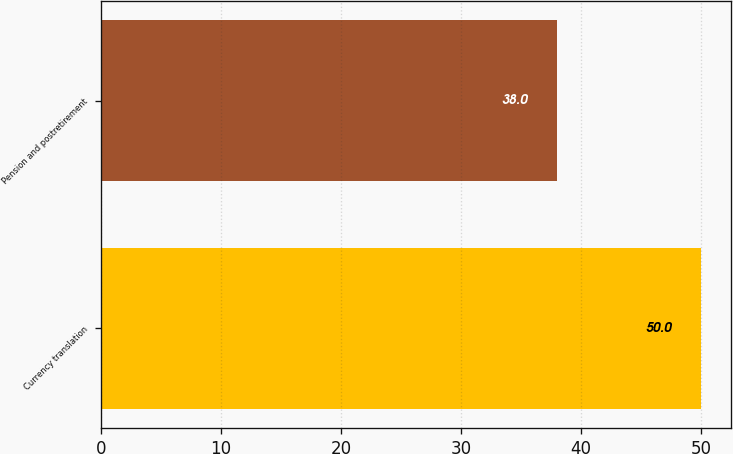<chart> <loc_0><loc_0><loc_500><loc_500><bar_chart><fcel>Currency translation<fcel>Pension and postretirement<nl><fcel>50<fcel>38<nl></chart> 